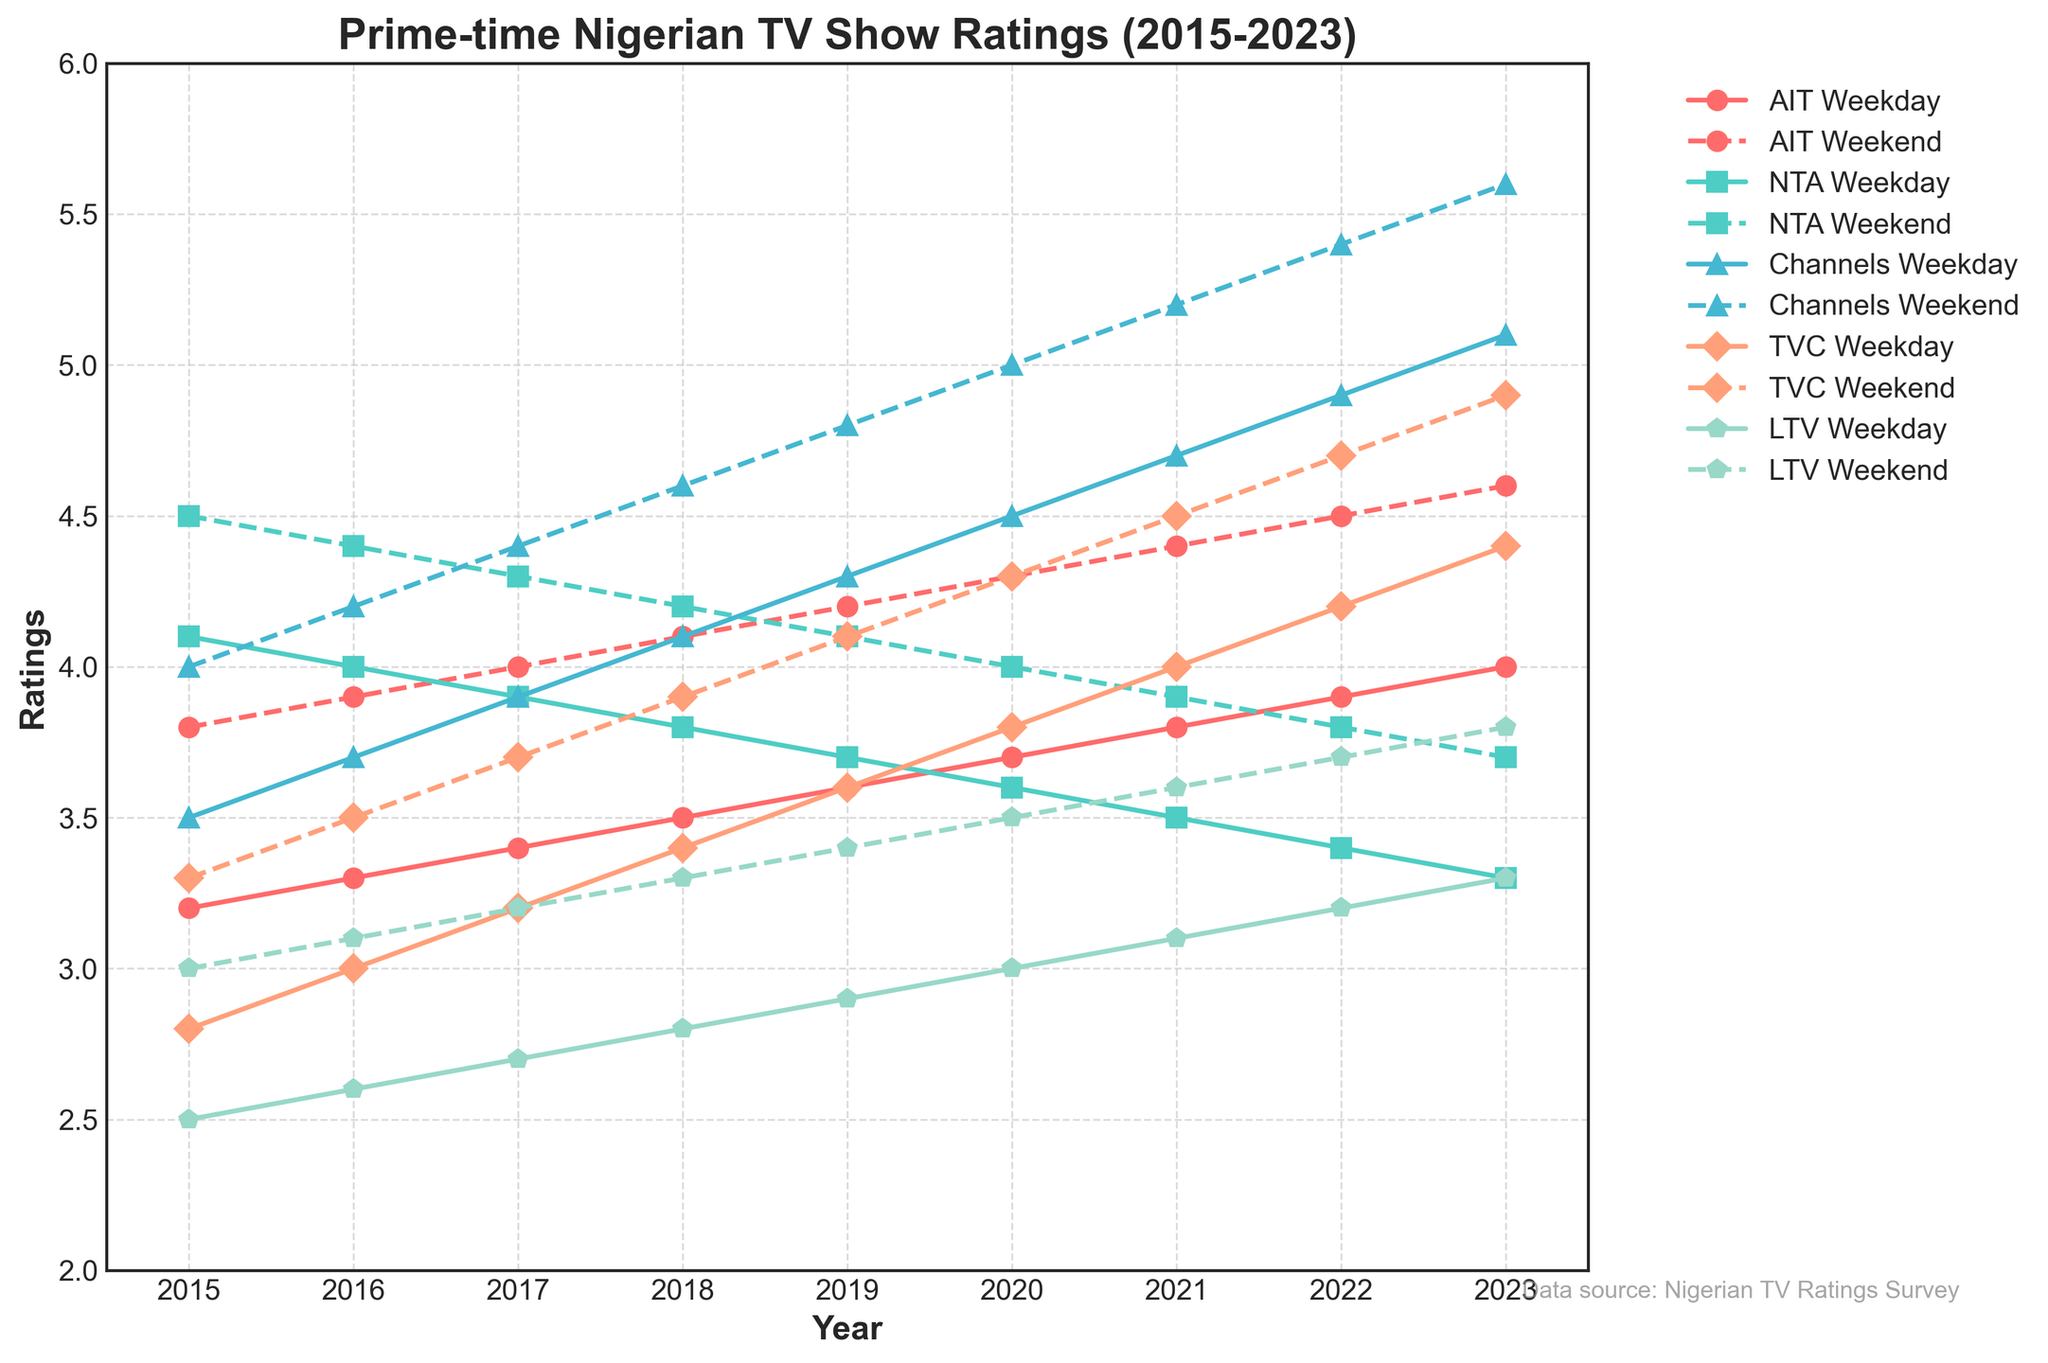Which network had higher ratings on weekdays in 2015, AIT or Channels? To compare the weekday ratings of AIT and Channels in 2015, refer to the plot and observe the values on the Y-axis corresponding to the year 2015 for both AIT and Channels. AIT has a weekday rating of 3.2 while Channels has a weekday rating of 3.5. Hence, Channels had higher ratings on weekdays in 2015.
Answer: Channels How do the weekend ratings of TVC in 2022 compare to NTA's weekend ratings in 2022? Look at the plot for the ratings of TVC and NTA during the weekends of 2022. TVC has a weekend rating of 4.7 and NTA has a weekend rating of 3.8. Hence, TVC had higher weekend ratings compared to NTA in 2022.
Answer: TVC On average, how much did AIT's weekday ratings increase per year from 2015 to 2023? To calculate the average increase per year, first find the difference in ratings from 2023 and 2015 for AIT on weekdays. The ratings are 4.0 (2023) and 3.2 (2015), resulting in an increase of 4.0 - 3.2 = 0.8. With 8 years between 2015 and 2023, the average increase per year is 0.8 / 8.
Answer: 0.1 Which channel had the lowest weekend ratings in 2020? Check which weekend ratings are plotted the lowest in 2020 by observing the lowest value on the Y-axis. LTV has a rating of 3.5, which is the lowest compared to the others.
Answer: LTV What is the trend in Channels TV's weekend ratings from 2015 to 2023? Observe the change in weekend ratings for Channels TV over the years. The ratings start at 4.0 in 2015 and increase each year until reaching 5.6 in 2023. The trend is consistently upward.
Answer: Increasing In which year did AIT have equal ratings for both weekdays and weekends? Find the point on the plot where the weekday and weekend lines for AIT intersect. This happens in 2016, where both ratings are equal at 3.9.
Answer: 2016 By how much did TVC's weekend ratings surpass its weekday ratings in 2021? Look at the weekend and weekday ratings for TVC in 2021. The weekend rating is 4.5 while the weekday rating is 4.0, the difference being 4.5 - 4.0 = 0.5.
Answer: 0.5 For which years did NTA's weekend ratings decrease compared to the previous year? Examine the plot for the trend in NTA's weekend ratings for each subsequent year. The ratings decreased from 4.5 to 4.4 in 2016 and from 3.9 to 3.8 in 2022.
Answer: 2016, 2022 